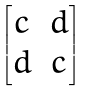Convert formula to latex. <formula><loc_0><loc_0><loc_500><loc_500>\begin{bmatrix} c & d \\ d & c \end{bmatrix}</formula> 